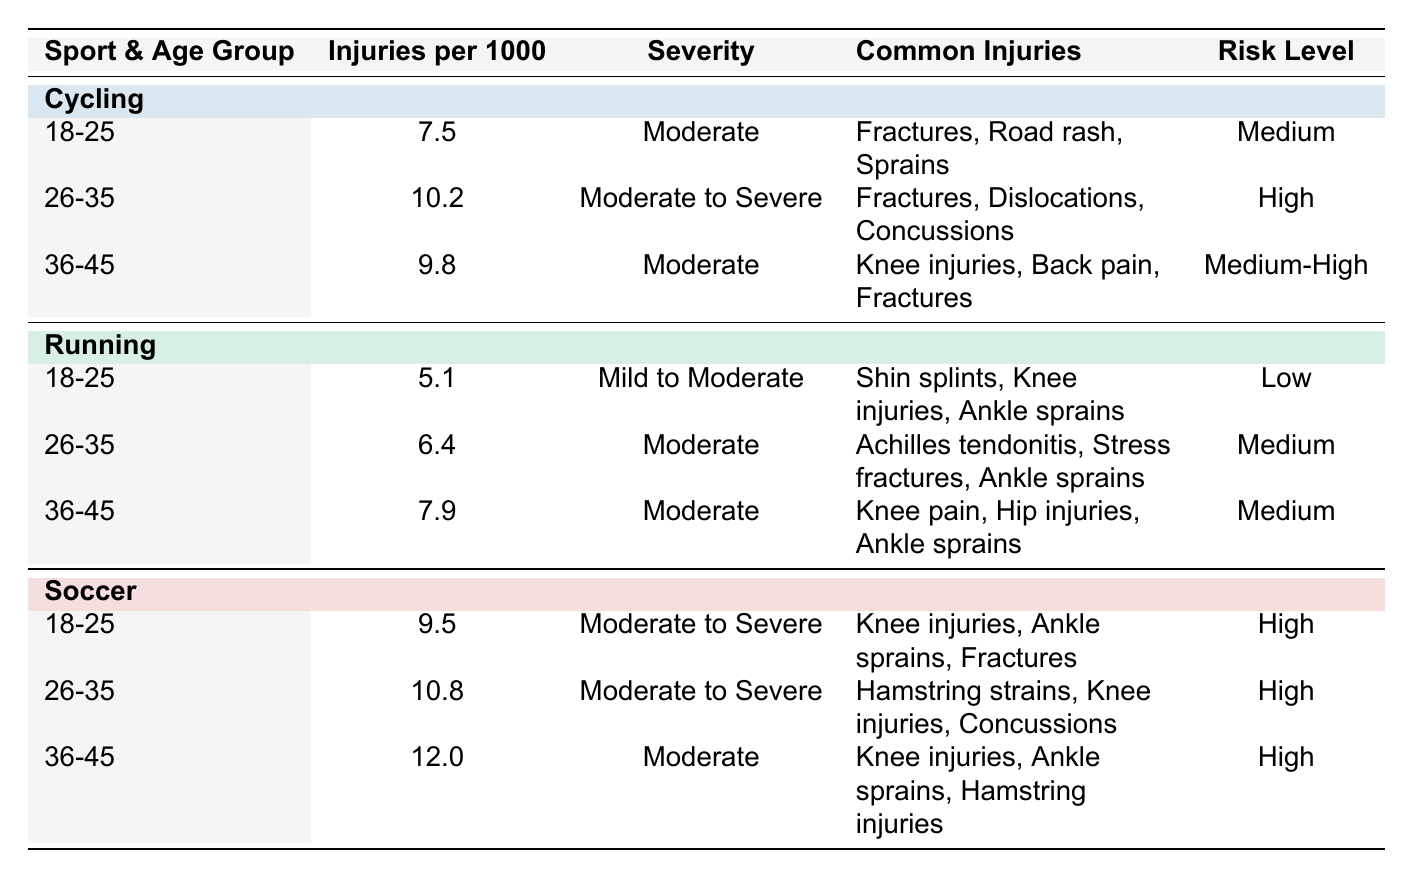What's the injury rate for cycling participants aged 18-25? The table shows that for cycling participants in this age group, the injury rate is 7.5 injuries per 1000 participants.
Answer: 7.5 Which sport has the highest injury rate for participants aged 36-45? Comparing the injury rates for participants aged 36-45: Cycling has 9.8, Running has 7.9, and Soccer has 12.0. Therefore, Soccer has the highest injury rate at 12.0 injuries per 1000 participants.
Answer: Soccer What is the average injury rate for all age groups in cycling? The injury rates for cycling across all age groups are 7.5, 10.2, and 9.8. Adding these gives 27.5, and dividing by 3 (the number of age groups) results in an average of 9.17 injuries per 1000 participants.
Answer: 9.17 Is it true that the common injuries for cyclists in the 26-35 age group include concussions? The table explicitly lists concussions as a common injury for the cycling participants in the 26-35 age group. Therefore, the statement is true.
Answer: Yes If we compare the injury rates of running and cycling for the age group 26-35, which sport has a higher rate? Cycling has an injury rate of 10.2, while Running has a rate of 6.4 for the age group 26-35. Since 10.2 is greater than 6.4, cycling has a higher injury rate in this comparison.
Answer: Cycling What is the total number of injuries per 1000 participants for soccer in the 18-25 and 26-35 age groups? Soccer has injury rates of 9.5 for the 18-25 age group and 10.8 for the 26-35 age group. Adding these two rates gives 9.5 + 10.8 = 20.3 injuries per 1000 participants for those age groups combined.
Answer: 20.3 In which age group does cycling have the same severity classification as soccer? Cycling has a "Moderate to Severe" classification in the 26-35 age group, and Soccer also has this classification for the same age group. Thus, the age group is 26-35.
Answer: 26-35 Is there any age group in running where the injury rate exceeds 8 injuries per 1000 participants? Checking the injury rates for running: 5.1 for 18-25, 6.4 for 26-35, and 7.9 for 36-45. None of these rates exceed 8, confirming the statement is false.
Answer: No What is the severity classification for cycling participants aged 36-45? The table indicates that cycling participants in the 36-45 age group have a severity classification of "Moderate."
Answer: Moderate 